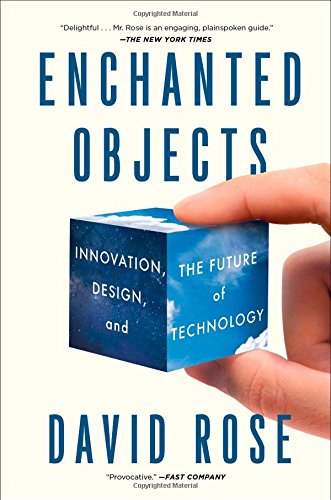Who wrote this book?
Answer the question using a single word or phrase. David Rose What is the title of this book? Enchanted Objects: Innovation, Design, and the Future of Technology What is the genre of this book? Arts & Photography Is this an art related book? Yes Is this a journey related book? No 